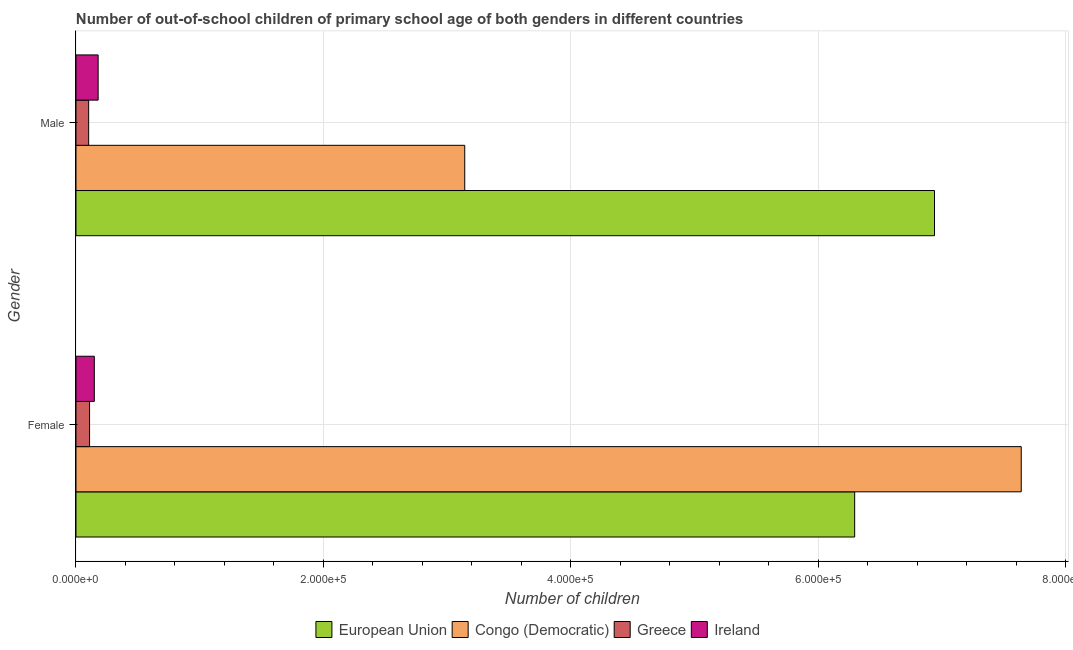How many different coloured bars are there?
Your answer should be compact. 4. How many groups of bars are there?
Keep it short and to the point. 2. Are the number of bars on each tick of the Y-axis equal?
Your response must be concise. Yes. How many bars are there on the 2nd tick from the bottom?
Give a very brief answer. 4. What is the label of the 1st group of bars from the top?
Offer a very short reply. Male. What is the number of male out-of-school students in European Union?
Provide a succinct answer. 6.94e+05. Across all countries, what is the maximum number of female out-of-school students?
Keep it short and to the point. 7.64e+05. Across all countries, what is the minimum number of female out-of-school students?
Keep it short and to the point. 1.10e+04. In which country was the number of female out-of-school students minimum?
Your answer should be very brief. Greece. What is the total number of male out-of-school students in the graph?
Your response must be concise. 1.04e+06. What is the difference between the number of female out-of-school students in Congo (Democratic) and that in Greece?
Offer a very short reply. 7.53e+05. What is the difference between the number of female out-of-school students in Ireland and the number of male out-of-school students in Greece?
Your answer should be compact. 4583. What is the average number of male out-of-school students per country?
Give a very brief answer. 2.59e+05. What is the difference between the number of male out-of-school students and number of female out-of-school students in Congo (Democratic)?
Your answer should be very brief. -4.50e+05. What is the ratio of the number of male out-of-school students in Ireland to that in European Union?
Provide a succinct answer. 0.03. Is the number of male out-of-school students in Ireland less than that in Greece?
Ensure brevity in your answer.  No. In how many countries, is the number of female out-of-school students greater than the average number of female out-of-school students taken over all countries?
Your response must be concise. 2. What does the 1st bar from the top in Female represents?
Keep it short and to the point. Ireland. What does the 4th bar from the bottom in Male represents?
Make the answer very short. Ireland. Are all the bars in the graph horizontal?
Ensure brevity in your answer.  Yes. What is the difference between two consecutive major ticks on the X-axis?
Your answer should be compact. 2.00e+05. Are the values on the major ticks of X-axis written in scientific E-notation?
Make the answer very short. Yes. Does the graph contain any zero values?
Provide a short and direct response. No. Where does the legend appear in the graph?
Give a very brief answer. Bottom center. How many legend labels are there?
Your answer should be compact. 4. What is the title of the graph?
Give a very brief answer. Number of out-of-school children of primary school age of both genders in different countries. What is the label or title of the X-axis?
Your answer should be very brief. Number of children. What is the Number of children of European Union in Female?
Your response must be concise. 6.29e+05. What is the Number of children in Congo (Democratic) in Female?
Your answer should be very brief. 7.64e+05. What is the Number of children in Greece in Female?
Ensure brevity in your answer.  1.10e+04. What is the Number of children of Ireland in Female?
Give a very brief answer. 1.48e+04. What is the Number of children of European Union in Male?
Ensure brevity in your answer.  6.94e+05. What is the Number of children of Congo (Democratic) in Male?
Make the answer very short. 3.14e+05. What is the Number of children of Greece in Male?
Keep it short and to the point. 1.02e+04. What is the Number of children in Ireland in Male?
Offer a very short reply. 1.79e+04. Across all Gender, what is the maximum Number of children in European Union?
Your answer should be very brief. 6.94e+05. Across all Gender, what is the maximum Number of children of Congo (Democratic)?
Provide a succinct answer. 7.64e+05. Across all Gender, what is the maximum Number of children of Greece?
Offer a terse response. 1.10e+04. Across all Gender, what is the maximum Number of children in Ireland?
Provide a succinct answer. 1.79e+04. Across all Gender, what is the minimum Number of children in European Union?
Your answer should be very brief. 6.29e+05. Across all Gender, what is the minimum Number of children of Congo (Democratic)?
Offer a very short reply. 3.14e+05. Across all Gender, what is the minimum Number of children in Greece?
Give a very brief answer. 1.02e+04. Across all Gender, what is the minimum Number of children of Ireland?
Ensure brevity in your answer.  1.48e+04. What is the total Number of children in European Union in the graph?
Provide a short and direct response. 1.32e+06. What is the total Number of children of Congo (Democratic) in the graph?
Give a very brief answer. 1.08e+06. What is the total Number of children in Greece in the graph?
Offer a very short reply. 2.12e+04. What is the total Number of children of Ireland in the graph?
Your answer should be very brief. 3.27e+04. What is the difference between the Number of children in European Union in Female and that in Male?
Give a very brief answer. -6.45e+04. What is the difference between the Number of children of Congo (Democratic) in Female and that in Male?
Offer a terse response. 4.50e+05. What is the difference between the Number of children of Greece in Female and that in Male?
Your answer should be compact. 754. What is the difference between the Number of children in Ireland in Female and that in Male?
Provide a short and direct response. -3080. What is the difference between the Number of children in European Union in Female and the Number of children in Congo (Democratic) in Male?
Make the answer very short. 3.15e+05. What is the difference between the Number of children in European Union in Female and the Number of children in Greece in Male?
Your response must be concise. 6.19e+05. What is the difference between the Number of children of European Union in Female and the Number of children of Ireland in Male?
Provide a succinct answer. 6.12e+05. What is the difference between the Number of children in Congo (Democratic) in Female and the Number of children in Greece in Male?
Offer a very short reply. 7.54e+05. What is the difference between the Number of children of Congo (Democratic) in Female and the Number of children of Ireland in Male?
Ensure brevity in your answer.  7.46e+05. What is the difference between the Number of children in Greece in Female and the Number of children in Ireland in Male?
Provide a short and direct response. -6909. What is the average Number of children in European Union per Gender?
Your answer should be very brief. 6.62e+05. What is the average Number of children of Congo (Democratic) per Gender?
Keep it short and to the point. 5.39e+05. What is the average Number of children of Greece per Gender?
Keep it short and to the point. 1.06e+04. What is the average Number of children in Ireland per Gender?
Your answer should be very brief. 1.64e+04. What is the difference between the Number of children in European Union and Number of children in Congo (Democratic) in Female?
Keep it short and to the point. -1.35e+05. What is the difference between the Number of children of European Union and Number of children of Greece in Female?
Offer a terse response. 6.18e+05. What is the difference between the Number of children in European Union and Number of children in Ireland in Female?
Provide a short and direct response. 6.15e+05. What is the difference between the Number of children in Congo (Democratic) and Number of children in Greece in Female?
Keep it short and to the point. 7.53e+05. What is the difference between the Number of children in Congo (Democratic) and Number of children in Ireland in Female?
Give a very brief answer. 7.49e+05. What is the difference between the Number of children in Greece and Number of children in Ireland in Female?
Provide a succinct answer. -3829. What is the difference between the Number of children of European Union and Number of children of Congo (Democratic) in Male?
Provide a short and direct response. 3.80e+05. What is the difference between the Number of children of European Union and Number of children of Greece in Male?
Make the answer very short. 6.84e+05. What is the difference between the Number of children of European Union and Number of children of Ireland in Male?
Your answer should be compact. 6.76e+05. What is the difference between the Number of children in Congo (Democratic) and Number of children in Greece in Male?
Offer a terse response. 3.04e+05. What is the difference between the Number of children in Congo (Democratic) and Number of children in Ireland in Male?
Your response must be concise. 2.96e+05. What is the difference between the Number of children in Greece and Number of children in Ireland in Male?
Make the answer very short. -7663. What is the ratio of the Number of children of European Union in Female to that in Male?
Offer a terse response. 0.91. What is the ratio of the Number of children in Congo (Democratic) in Female to that in Male?
Make the answer very short. 2.43. What is the ratio of the Number of children of Greece in Female to that in Male?
Keep it short and to the point. 1.07. What is the ratio of the Number of children of Ireland in Female to that in Male?
Give a very brief answer. 0.83. What is the difference between the highest and the second highest Number of children in European Union?
Make the answer very short. 6.45e+04. What is the difference between the highest and the second highest Number of children in Congo (Democratic)?
Your response must be concise. 4.50e+05. What is the difference between the highest and the second highest Number of children of Greece?
Your answer should be compact. 754. What is the difference between the highest and the second highest Number of children in Ireland?
Provide a succinct answer. 3080. What is the difference between the highest and the lowest Number of children in European Union?
Provide a short and direct response. 6.45e+04. What is the difference between the highest and the lowest Number of children of Congo (Democratic)?
Provide a short and direct response. 4.50e+05. What is the difference between the highest and the lowest Number of children in Greece?
Your answer should be compact. 754. What is the difference between the highest and the lowest Number of children in Ireland?
Provide a succinct answer. 3080. 